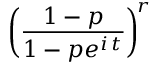<formula> <loc_0><loc_0><loc_500><loc_500>\, { \left ( } { \frac { 1 - p } { 1 - p e ^ { i \, t } } } { \right ) } ^ { \, r }</formula> 